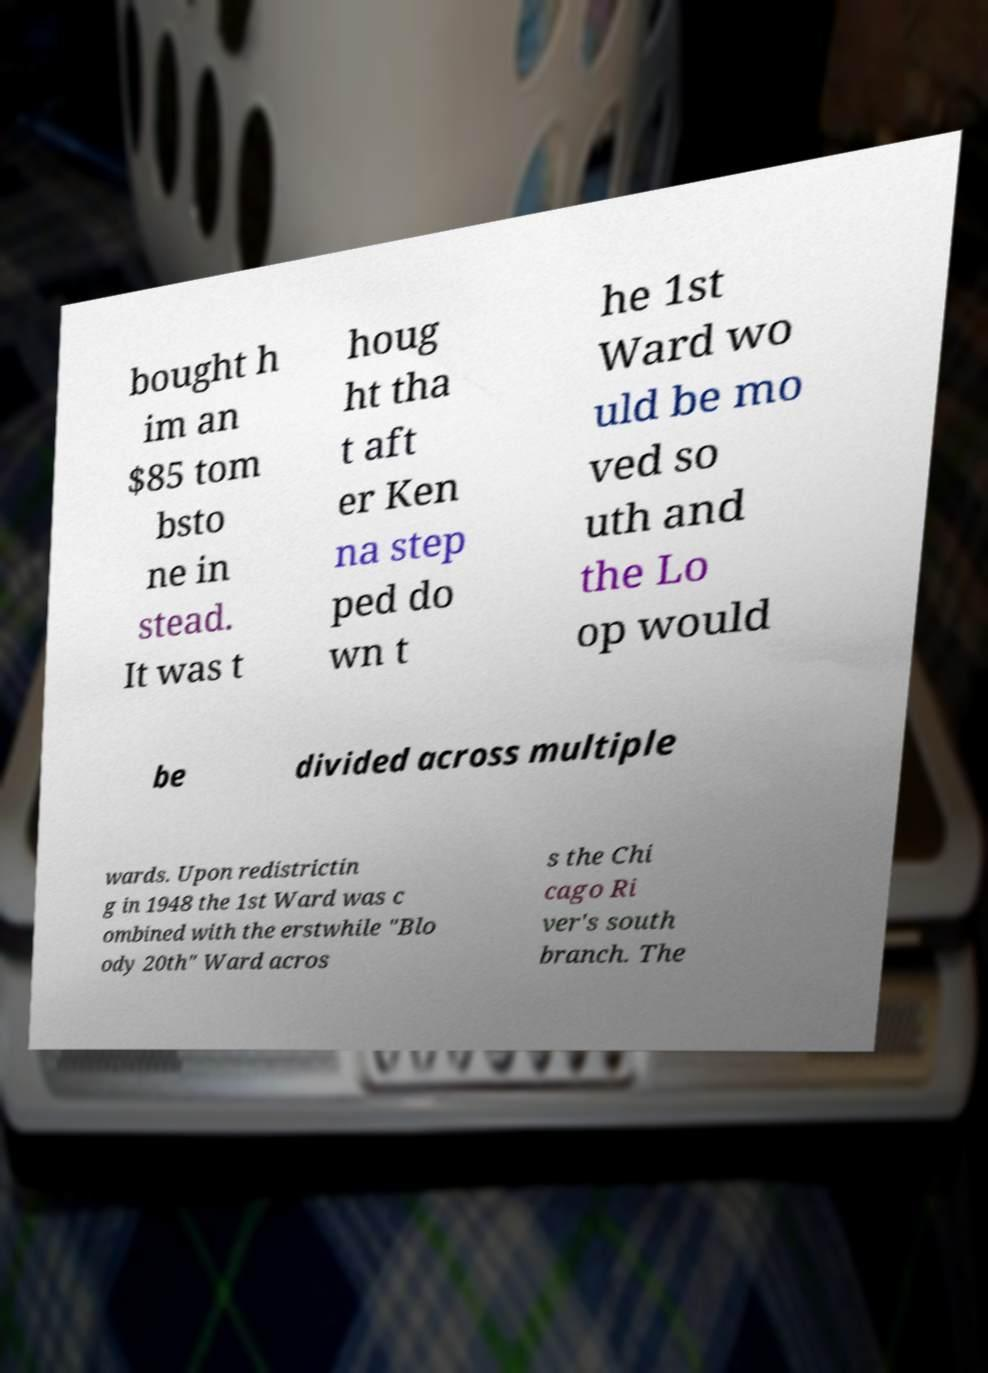Please read and relay the text visible in this image. What does it say? bought h im an $85 tom bsto ne in stead. It was t houg ht tha t aft er Ken na step ped do wn t he 1st Ward wo uld be mo ved so uth and the Lo op would be divided across multiple wards. Upon redistrictin g in 1948 the 1st Ward was c ombined with the erstwhile "Blo ody 20th" Ward acros s the Chi cago Ri ver's south branch. The 